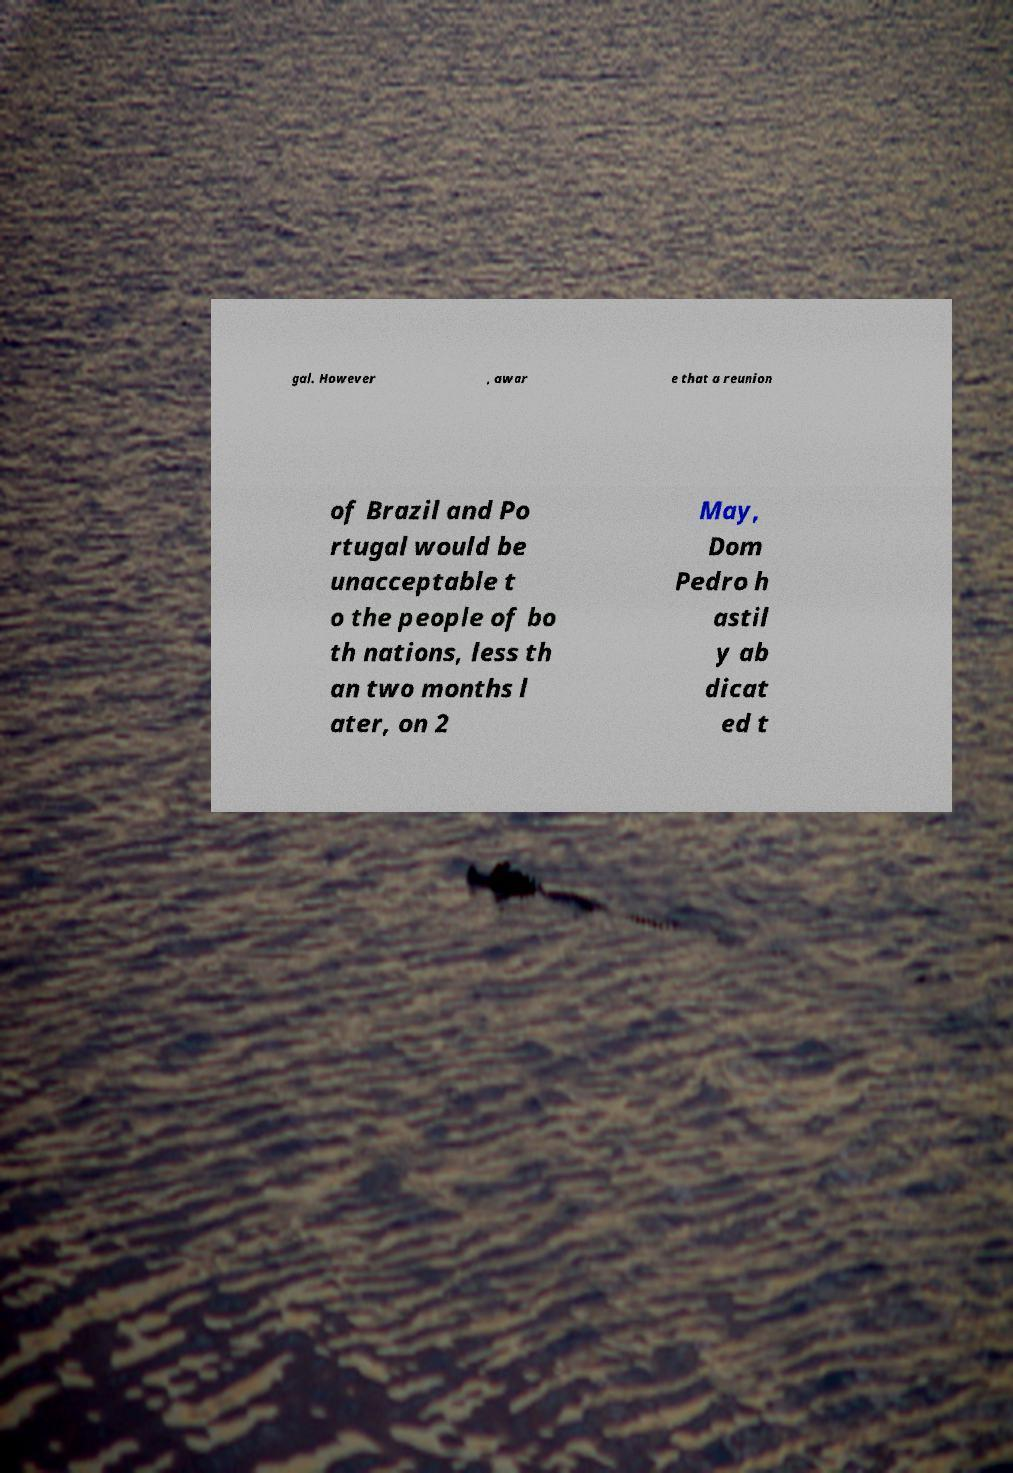Could you extract and type out the text from this image? gal. However , awar e that a reunion of Brazil and Po rtugal would be unacceptable t o the people of bo th nations, less th an two months l ater, on 2 May, Dom Pedro h astil y ab dicat ed t 